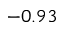<formula> <loc_0><loc_0><loc_500><loc_500>- 0 . 9 3</formula> 